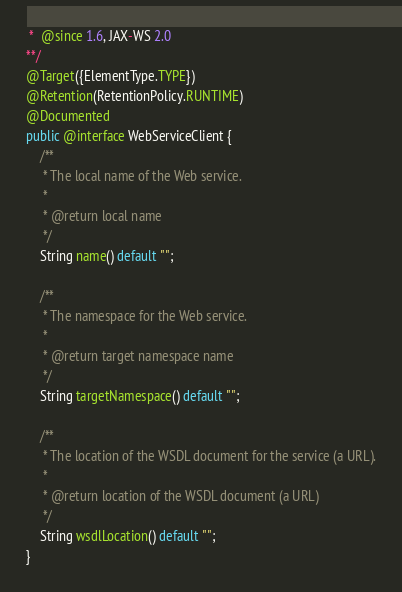<code> <loc_0><loc_0><loc_500><loc_500><_Java_> *  @since 1.6, JAX-WS 2.0
**/
@Target({ElementType.TYPE})
@Retention(RetentionPolicy.RUNTIME)
@Documented
public @interface WebServiceClient {
    /**
     * The local name of the Web service.
     *
     * @return local name
     */
    String name() default "";

    /**
     * The namespace for the Web service.
     *
     * @return target namespace name
     */
    String targetNamespace() default "";

    /**
     * The location of the WSDL document for the service (a URL).
     *
     * @return location of the WSDL document (a URL)
     */
    String wsdlLocation() default "";
}
</code> 